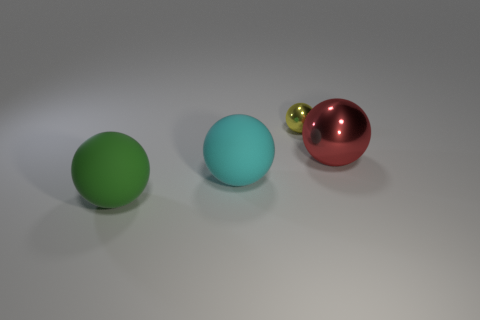Add 1 red metal spheres. How many objects exist? 5 Subtract all large balls. How many balls are left? 1 Subtract 2 balls. How many balls are left? 2 Subtract all yellow spheres. How many spheres are left? 3 Subtract all brown cylinders. How many green balls are left? 1 Subtract all tiny balls. Subtract all big cyan things. How many objects are left? 2 Add 4 matte objects. How many matte objects are left? 6 Add 1 tiny yellow metal things. How many tiny yellow metal things exist? 2 Subtract 0 purple cubes. How many objects are left? 4 Subtract all yellow balls. Subtract all purple cylinders. How many balls are left? 3 